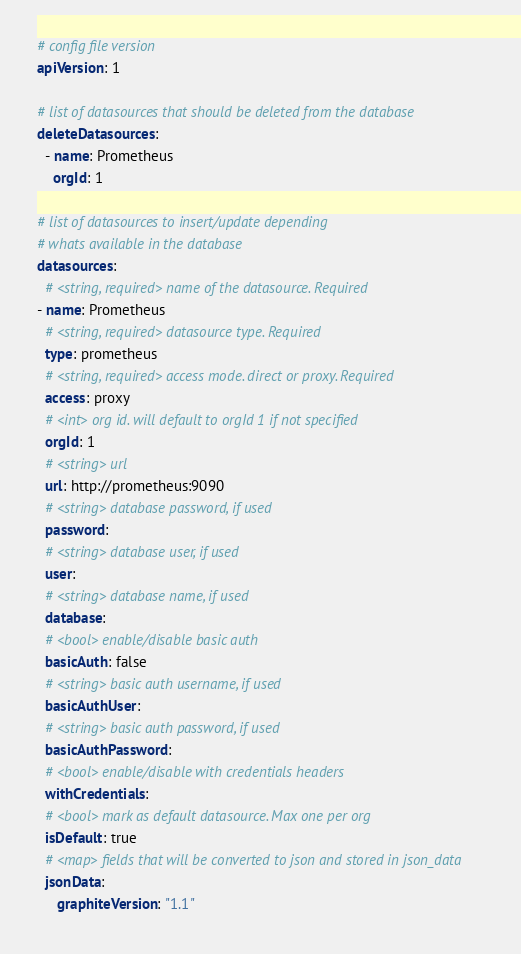Convert code to text. <code><loc_0><loc_0><loc_500><loc_500><_YAML_># config file version
apiVersion: 1

# list of datasources that should be deleted from the database
deleteDatasources:
  - name: Prometheus
    orgId: 1

# list of datasources to insert/update depending
# whats available in the database
datasources:
  # <string, required> name of the datasource. Required
- name: Prometheus
  # <string, required> datasource type. Required
  type: prometheus
  # <string, required> access mode. direct or proxy. Required
  access: proxy
  # <int> org id. will default to orgId 1 if not specified
  orgId: 1
  # <string> url
  url: http://prometheus:9090
  # <string> database password, if used
  password:
  # <string> database user, if used
  user:
  # <string> database name, if used
  database:
  # <bool> enable/disable basic auth
  basicAuth: false
  # <string> basic auth username, if used
  basicAuthUser:
  # <string> basic auth password, if used
  basicAuthPassword:
  # <bool> enable/disable with credentials headers
  withCredentials:
  # <bool> mark as default datasource. Max one per org
  isDefault: true
  # <map> fields that will be converted to json and stored in json_data
  jsonData:
     graphiteVersion: "1.1"</code> 